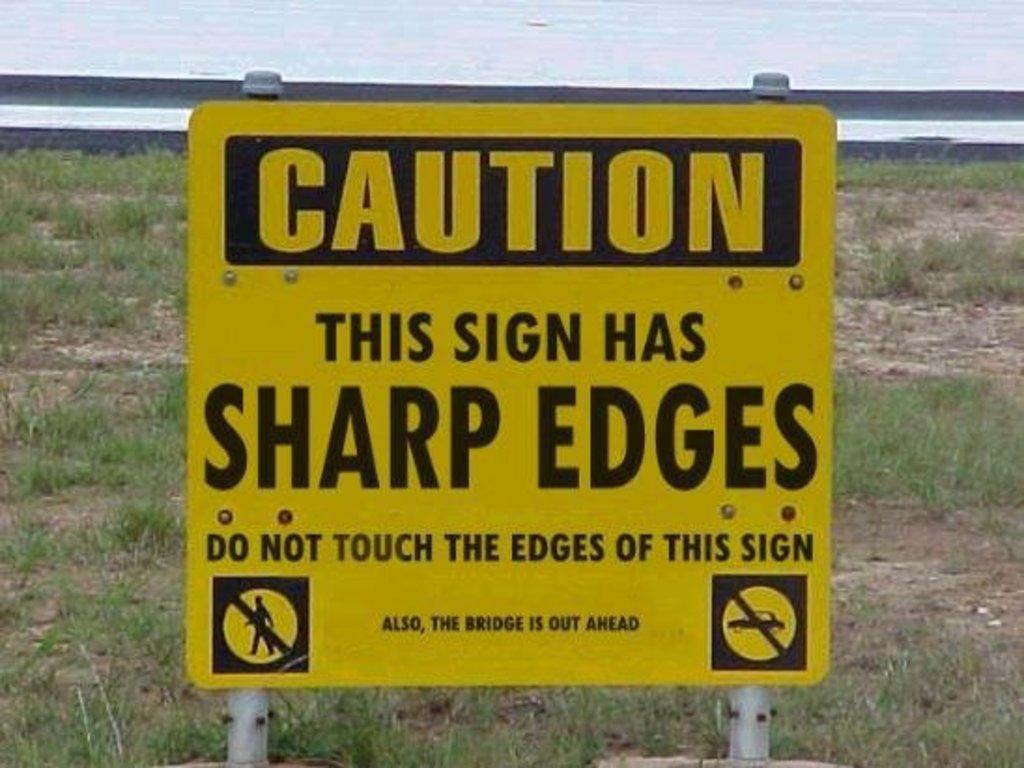<image>
Provide a brief description of the given image. A yellow sign in front of an empty lot cautions that it's edges are sharp. 